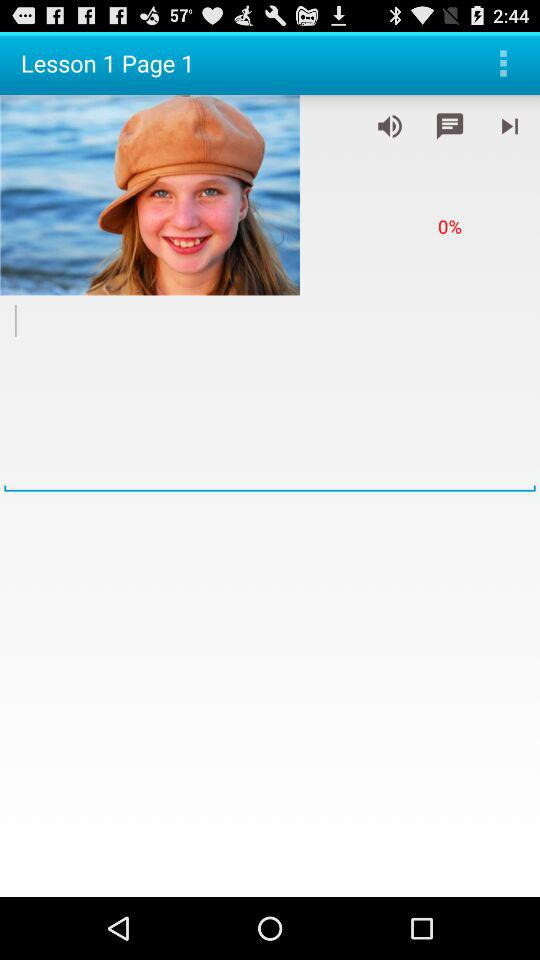What is the loading percentage? The loading percentage is 0. 